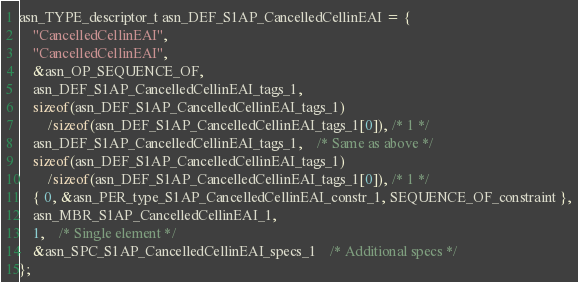Convert code to text. <code><loc_0><loc_0><loc_500><loc_500><_C_>asn_TYPE_descriptor_t asn_DEF_S1AP_CancelledCellinEAI = {
	"CancelledCellinEAI",
	"CancelledCellinEAI",
	&asn_OP_SEQUENCE_OF,
	asn_DEF_S1AP_CancelledCellinEAI_tags_1,
	sizeof(asn_DEF_S1AP_CancelledCellinEAI_tags_1)
		/sizeof(asn_DEF_S1AP_CancelledCellinEAI_tags_1[0]), /* 1 */
	asn_DEF_S1AP_CancelledCellinEAI_tags_1,	/* Same as above */
	sizeof(asn_DEF_S1AP_CancelledCellinEAI_tags_1)
		/sizeof(asn_DEF_S1AP_CancelledCellinEAI_tags_1[0]), /* 1 */
	{ 0, &asn_PER_type_S1AP_CancelledCellinEAI_constr_1, SEQUENCE_OF_constraint },
	asn_MBR_S1AP_CancelledCellinEAI_1,
	1,	/* Single element */
	&asn_SPC_S1AP_CancelledCellinEAI_specs_1	/* Additional specs */
};

</code> 